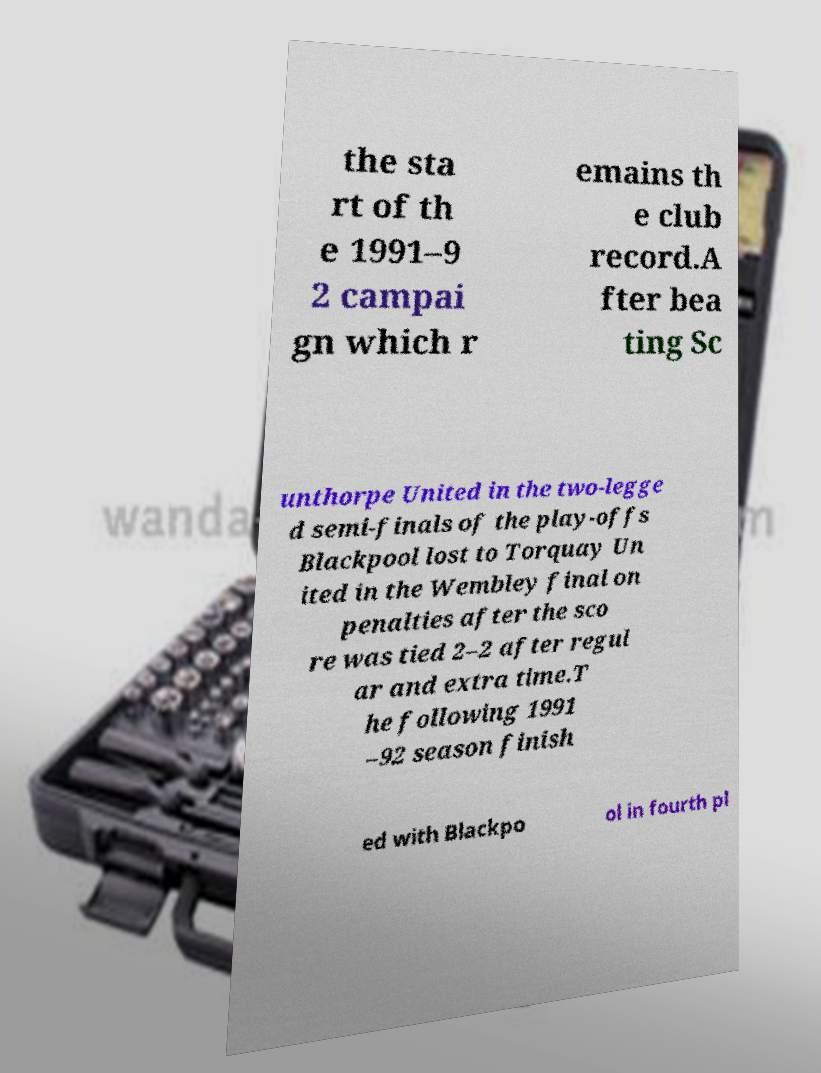Could you assist in decoding the text presented in this image and type it out clearly? the sta rt of th e 1991–9 2 campai gn which r emains th e club record.A fter bea ting Sc unthorpe United in the two-legge d semi-finals of the play-offs Blackpool lost to Torquay Un ited in the Wembley final on penalties after the sco re was tied 2–2 after regul ar and extra time.T he following 1991 –92 season finish ed with Blackpo ol in fourth pl 